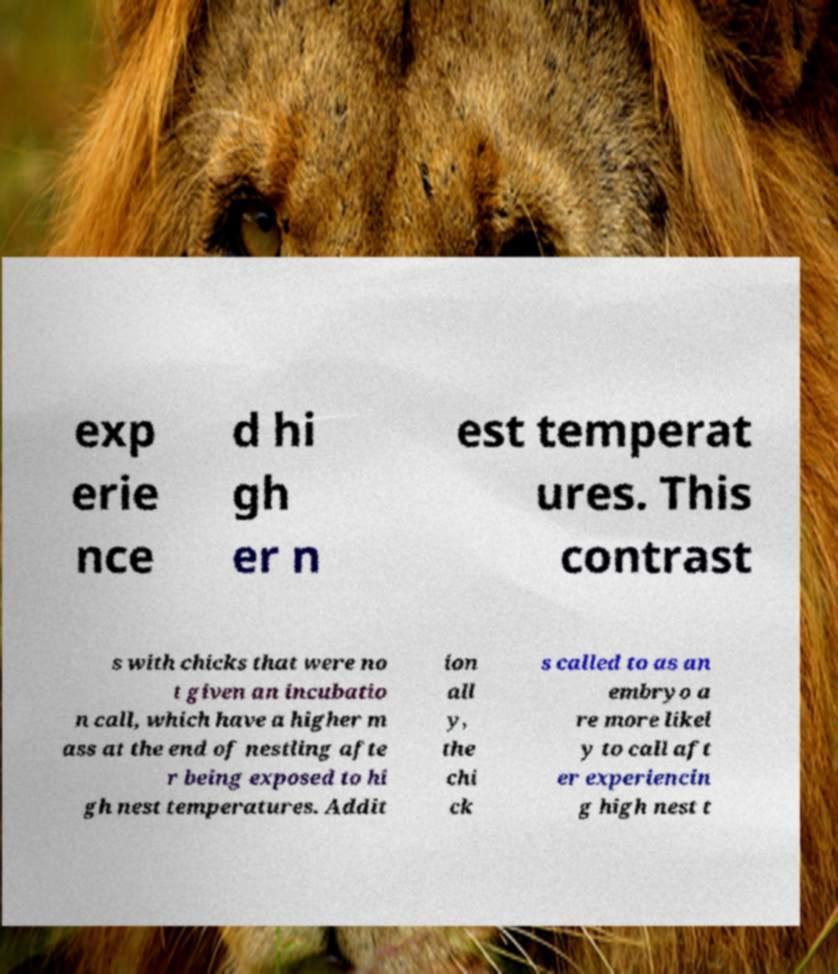Please identify and transcribe the text found in this image. exp erie nce d hi gh er n est temperat ures. This contrast s with chicks that were no t given an incubatio n call, which have a higher m ass at the end of nestling afte r being exposed to hi gh nest temperatures. Addit ion all y, the chi ck s called to as an embryo a re more likel y to call aft er experiencin g high nest t 